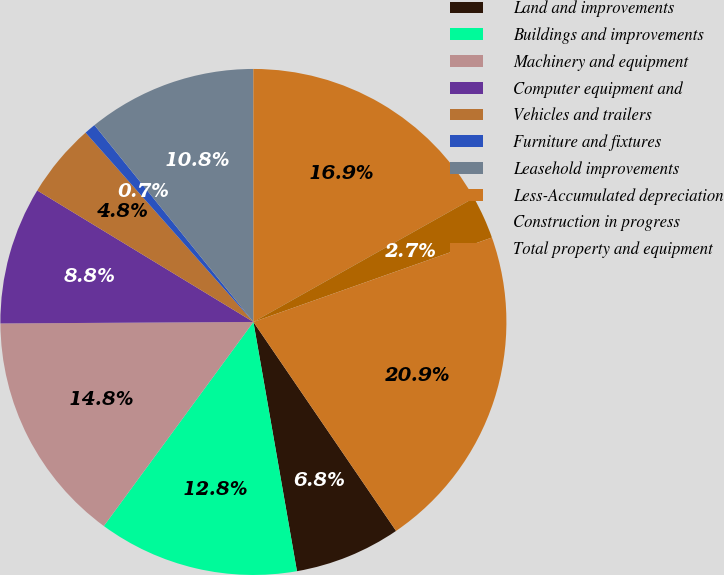Convert chart to OTSL. <chart><loc_0><loc_0><loc_500><loc_500><pie_chart><fcel>Land and improvements<fcel>Buildings and improvements<fcel>Machinery and equipment<fcel>Computer equipment and<fcel>Vehicles and trailers<fcel>Furniture and fixtures<fcel>Leasehold improvements<fcel>Less-Accumulated depreciation<fcel>Construction in progress<fcel>Total property and equipment<nl><fcel>6.78%<fcel>12.82%<fcel>14.84%<fcel>8.79%<fcel>4.76%<fcel>0.73%<fcel>10.81%<fcel>16.85%<fcel>2.74%<fcel>20.88%<nl></chart> 